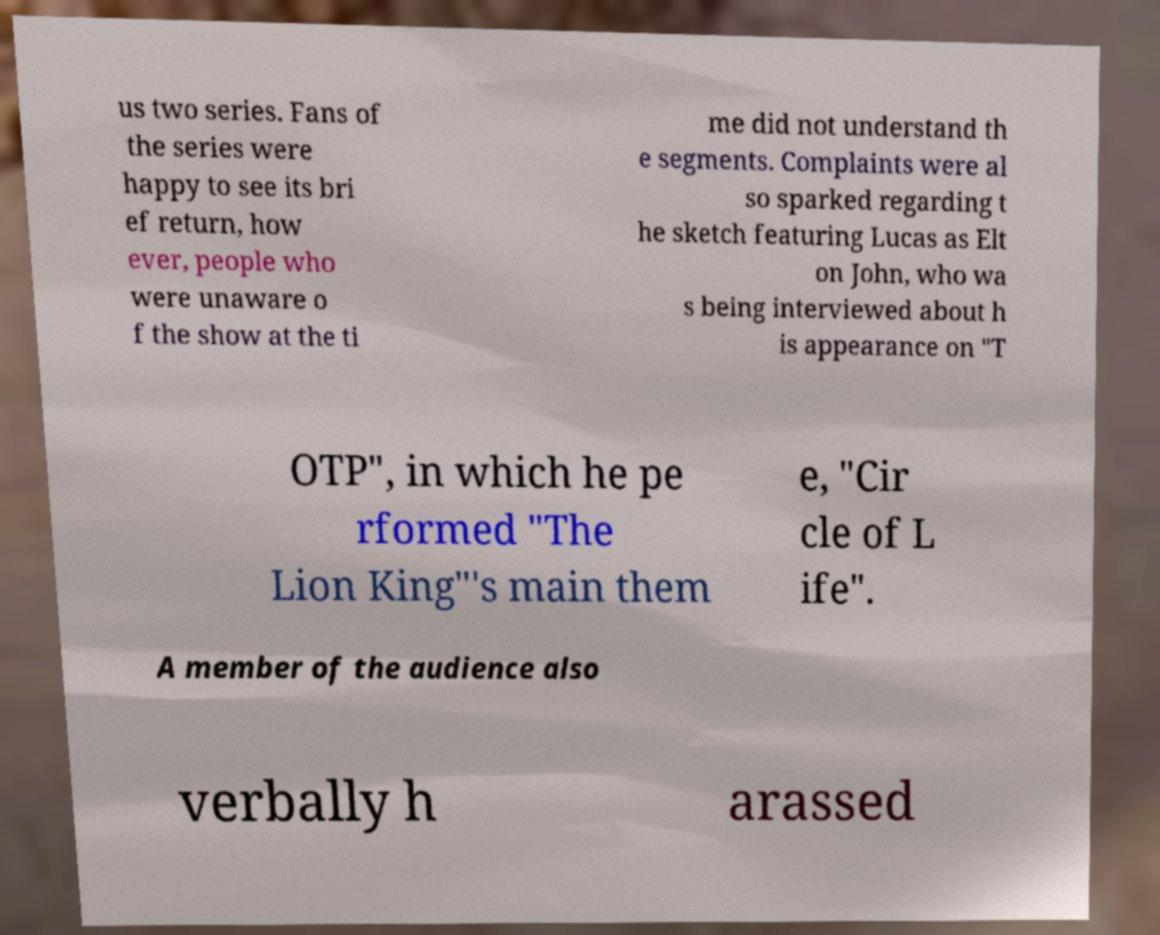Could you extract and type out the text from this image? us two series. Fans of the series were happy to see its bri ef return, how ever, people who were unaware o f the show at the ti me did not understand th e segments. Complaints were al so sparked regarding t he sketch featuring Lucas as Elt on John, who wa s being interviewed about h is appearance on "T OTP", in which he pe rformed "The Lion King"'s main them e, "Cir cle of L ife". A member of the audience also verbally h arassed 